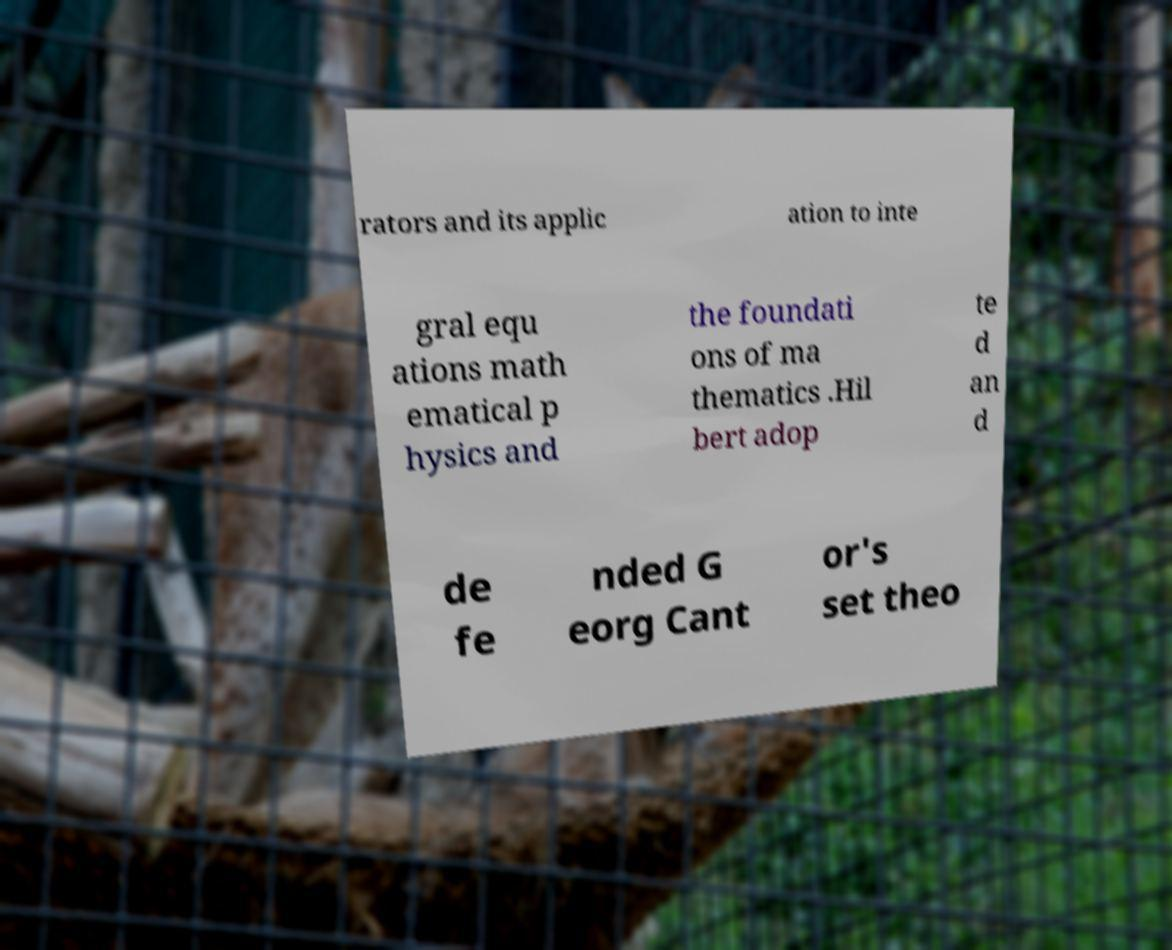Can you read and provide the text displayed in the image?This photo seems to have some interesting text. Can you extract and type it out for me? rators and its applic ation to inte gral equ ations math ematical p hysics and the foundati ons of ma thematics .Hil bert adop te d an d de fe nded G eorg Cant or's set theo 